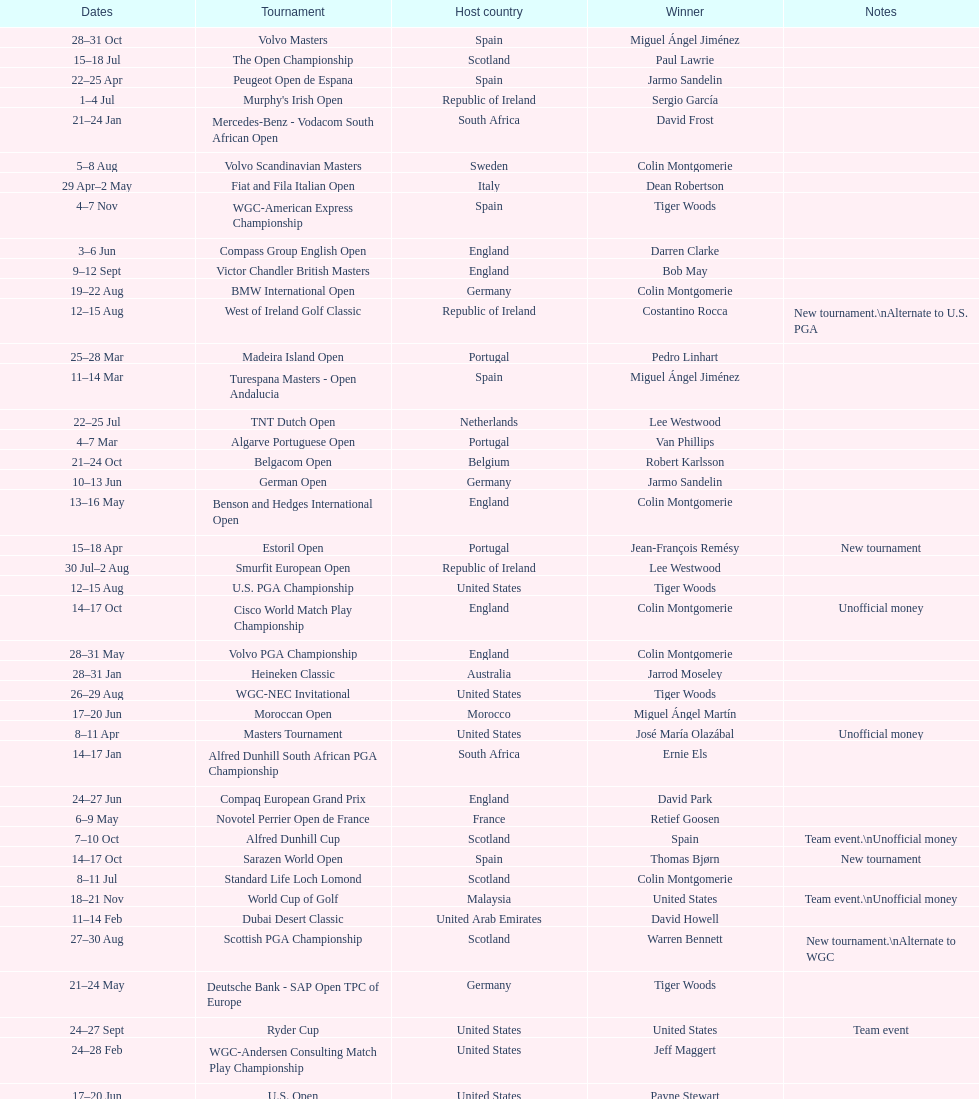Other than qatar masters, name a tournament that was in february. Dubai Desert Classic. 